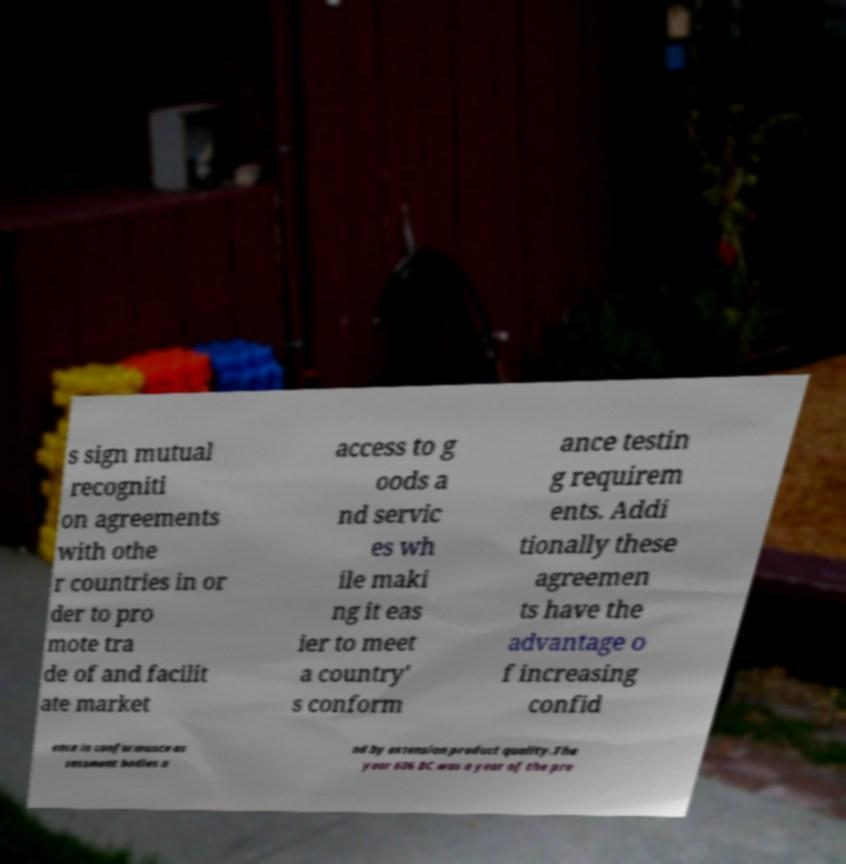Could you extract and type out the text from this image? s sign mutual recogniti on agreements with othe r countries in or der to pro mote tra de of and facilit ate market access to g oods a nd servic es wh ile maki ng it eas ier to meet a country' s conform ance testin g requirem ents. Addi tionally these agreemen ts have the advantage o f increasing confid ence in conformance as sessment bodies a nd by extension product quality.The year 606 BC was a year of the pre 